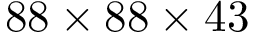Convert formula to latex. <formula><loc_0><loc_0><loc_500><loc_500>8 8 \times 8 8 \times 4 3</formula> 